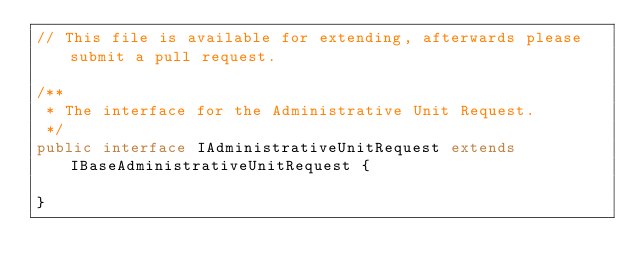<code> <loc_0><loc_0><loc_500><loc_500><_Java_>// This file is available for extending, afterwards please submit a pull request.

/**
 * The interface for the Administrative Unit Request.
 */
public interface IAdministrativeUnitRequest extends IBaseAdministrativeUnitRequest {

}
</code> 